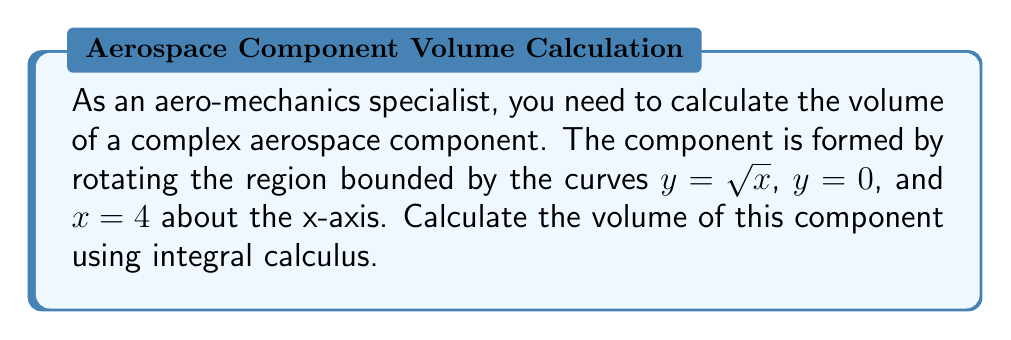Show me your answer to this math problem. To solve this problem, we'll use the method of volumes by rotation (shell method) since we're rotating around the x-axis:

1) The volume formula using the shell method is:
   $$V = 2\pi \int_a^b y \cdot x \, dy$$

2) We need to express x in terms of y:
   $y = \sqrt{x}$, so $x = y^2$

3) The limits of integration are from y = 0 to y = 2 (since $\sqrt{4} = 2$)

4) Substituting into the volume formula:
   $$V = 2\pi \int_0^2 y \cdot y^2 \, dy$$

5) Simplify:
   $$V = 2\pi \int_0^2 y^3 \, dy$$

6) Integrate:
   $$V = 2\pi \left[\frac{y^4}{4}\right]_0^2$$

7) Evaluate the definite integral:
   $$V = 2\pi \left(\frac{2^4}{4} - \frac{0^4}{4}\right) = 2\pi \left(\frac{16}{4}\right) = 8\pi$$

8) Therefore, the volume of the aerospace component is $8\pi$ cubic units.
Answer: $8\pi$ cubic units 